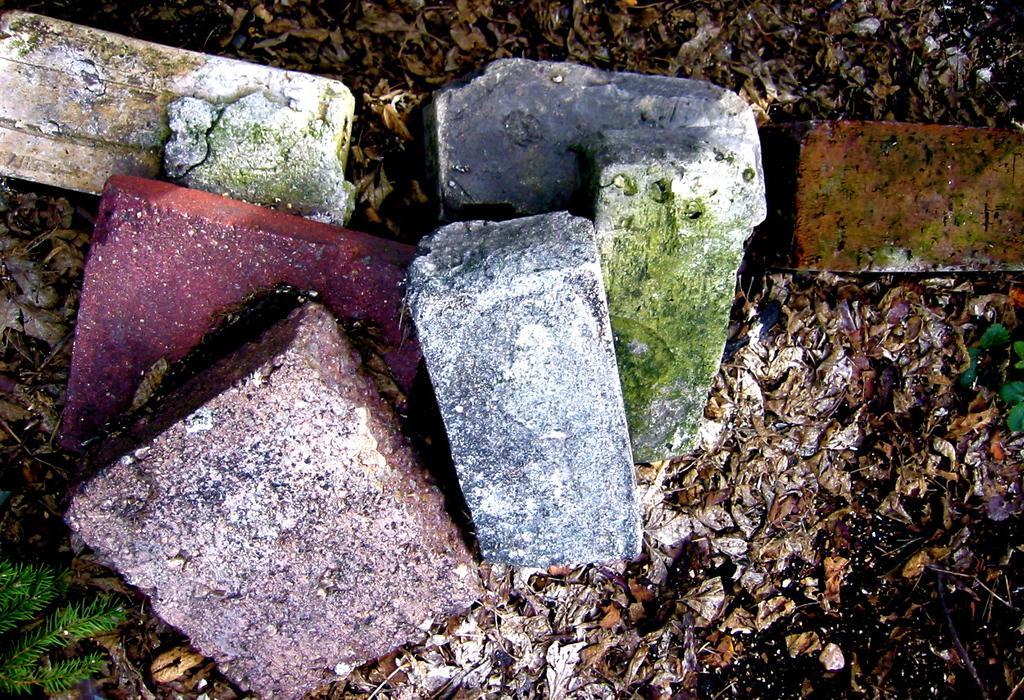In one or two sentences, can you explain what this image depicts? This picture is consists of colorful bricks in the image. 